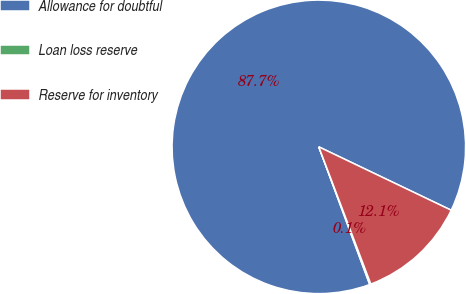Convert chart. <chart><loc_0><loc_0><loc_500><loc_500><pie_chart><fcel>Allowance for doubtful<fcel>Loan loss reserve<fcel>Reserve for inventory<nl><fcel>87.74%<fcel>0.13%<fcel>12.13%<nl></chart> 